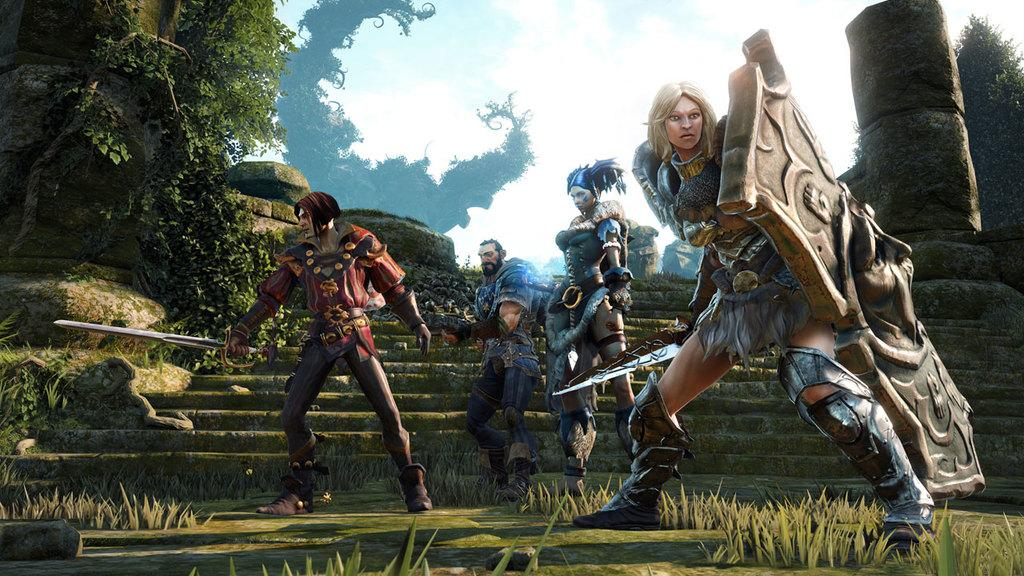Who is present in the image? There are people in the image. What are the people wearing? The people are wearing drama costumes. What type of natural environment can be seen in the image? There is grass in the image. Are there any architectural features present in the image? Yes, there are stairs in the image. What other natural elements can be seen in the image? There are stones and plants in the image. What type of ship can be seen in the image? There is no ship present in the image. How many kittens are playing with the plants in the image? There are no kittens present in the image; it only features people wearing drama costumes and various natural and architectural elements. 